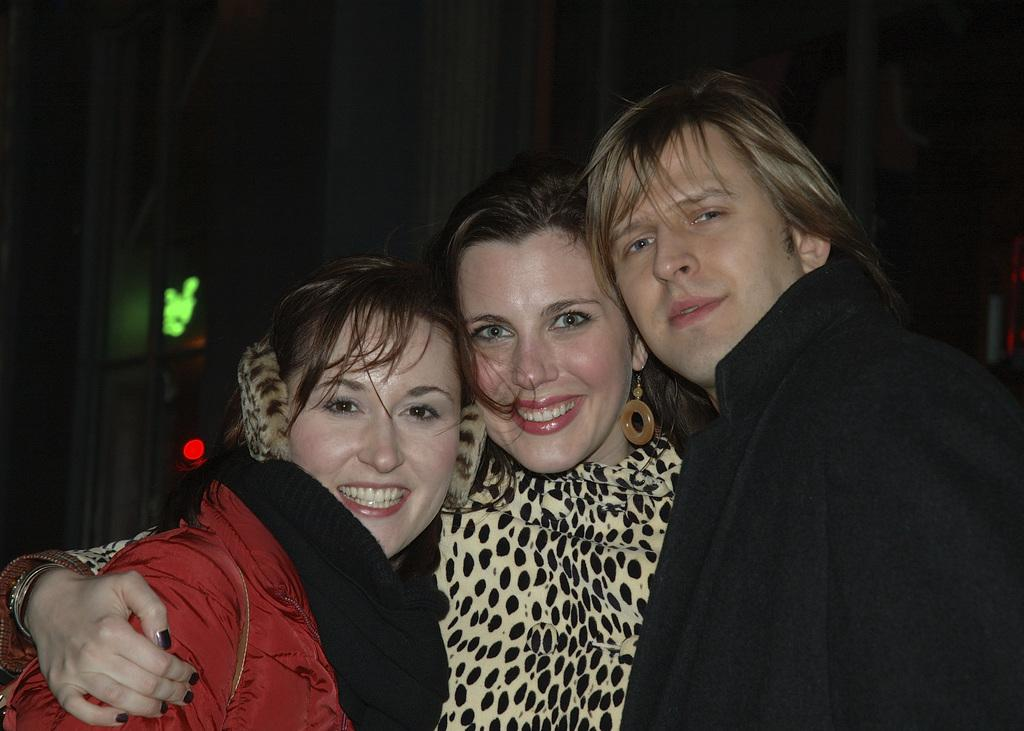How many people are in the image? There are three people in the image. Where are the people standing? The people are standing on a path. What can be seen in the background of the image? The background of the image is dark. What can be seen in addition to the people and the path? Lights are visible in the image. What type of zephyr can be seen blowing through the people's hair in the image? There is no zephyr present in the image, and the people's hair is not shown to be affected by any wind. 